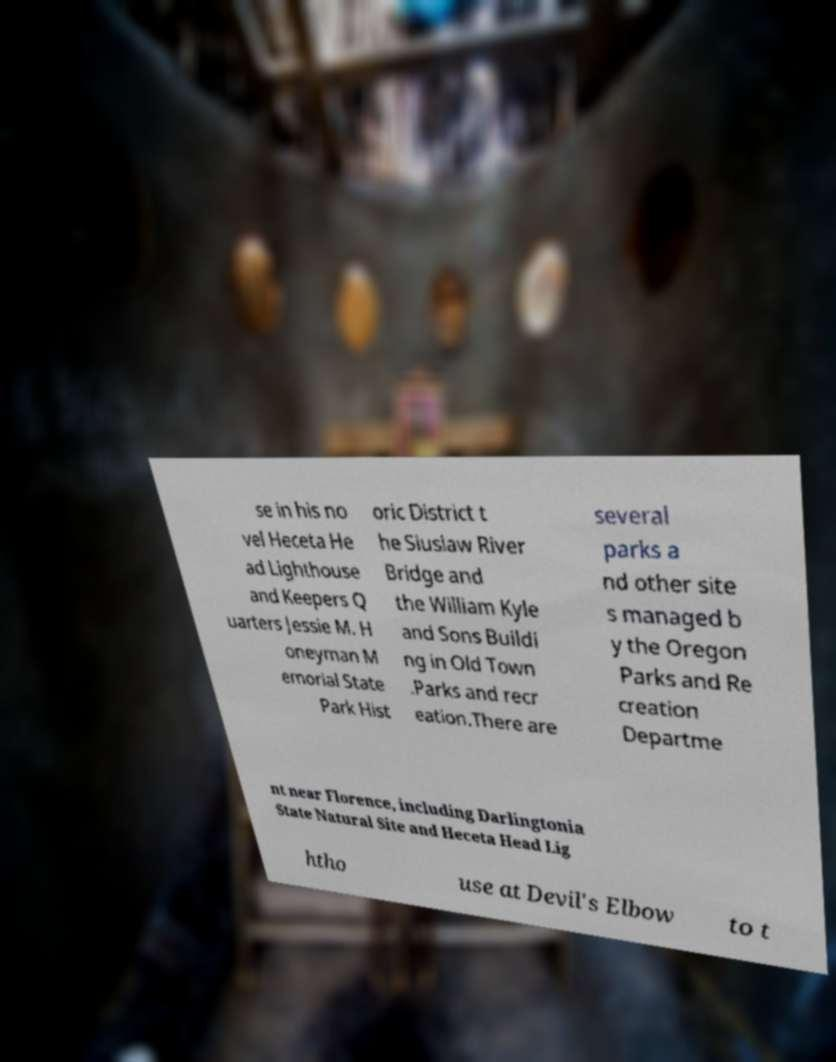Can you accurately transcribe the text from the provided image for me? se in his no vel Heceta He ad Lighthouse and Keepers Q uarters Jessie M. H oneyman M emorial State Park Hist oric District t he Siuslaw River Bridge and the William Kyle and Sons Buildi ng in Old Town .Parks and recr eation.There are several parks a nd other site s managed b y the Oregon Parks and Re creation Departme nt near Florence, including Darlingtonia State Natural Site and Heceta Head Lig htho use at Devil's Elbow to t 